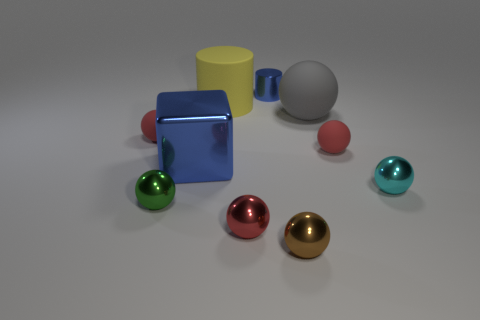Is the material of the tiny brown sphere the same as the cylinder that is to the left of the small shiny cylinder?
Provide a short and direct response. No. There is a blue cube that is the same size as the yellow matte thing; what material is it?
Provide a succinct answer. Metal. Is there a cube of the same size as the brown metallic object?
Your answer should be compact. No. There is a brown metallic object that is the same size as the red metallic object; what is its shape?
Give a very brief answer. Sphere. What number of other objects are there of the same color as the matte cylinder?
Your answer should be very brief. 0. The tiny object that is both behind the blue metallic cube and on the left side of the big rubber cylinder has what shape?
Give a very brief answer. Sphere. Are there any red objects that are in front of the shiny sphere that is on the right side of the large matte object on the right side of the large yellow rubber cylinder?
Offer a terse response. Yes. How many other things are made of the same material as the small blue thing?
Provide a succinct answer. 5. What number of tiny brown shiny blocks are there?
Provide a succinct answer. 0. What number of objects are small rubber balls or red shiny balls that are in front of the large cylinder?
Make the answer very short. 3. 